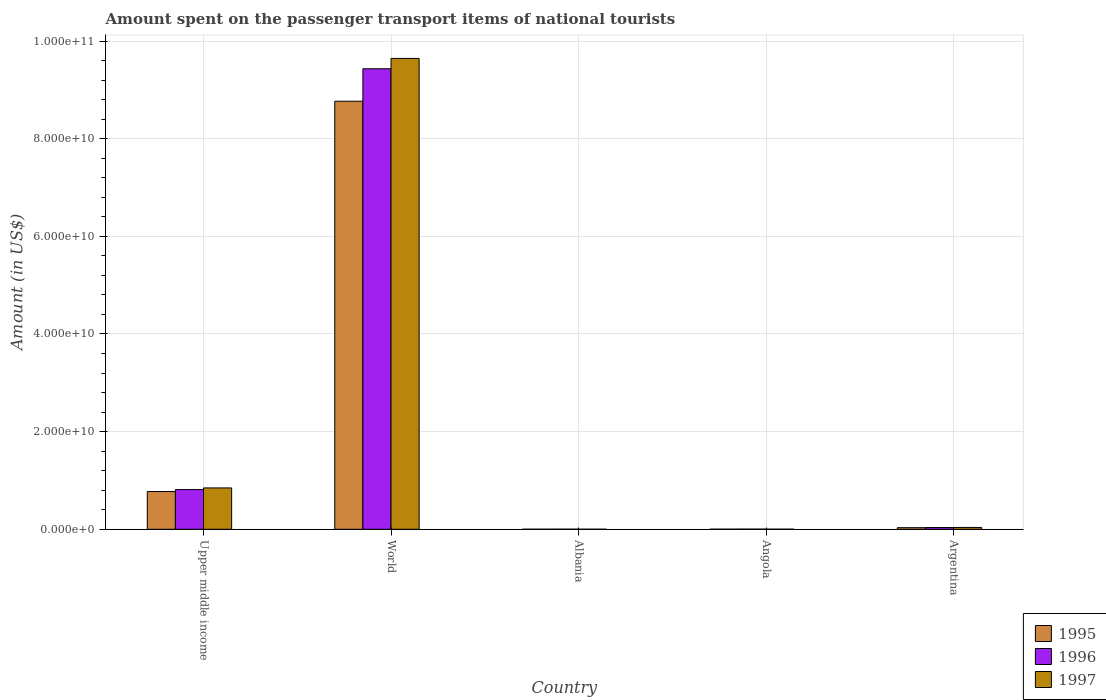How many different coloured bars are there?
Offer a terse response. 3. How many bars are there on the 3rd tick from the left?
Provide a succinct answer. 3. What is the label of the 4th group of bars from the left?
Make the answer very short. Angola. What is the amount spent on the passenger transport items of national tourists in 1997 in Upper middle income?
Your response must be concise. 8.47e+09. Across all countries, what is the maximum amount spent on the passenger transport items of national tourists in 1996?
Provide a succinct answer. 9.43e+1. Across all countries, what is the minimum amount spent on the passenger transport items of national tourists in 1996?
Give a very brief answer. 1.68e+07. In which country was the amount spent on the passenger transport items of national tourists in 1997 minimum?
Your answer should be very brief. Albania. What is the total amount spent on the passenger transport items of national tourists in 1996 in the graph?
Provide a succinct answer. 1.03e+11. What is the difference between the amount spent on the passenger transport items of national tourists in 1995 in Angola and that in Upper middle income?
Offer a terse response. -7.72e+09. What is the difference between the amount spent on the passenger transport items of national tourists in 1997 in Upper middle income and the amount spent on the passenger transport items of national tourists in 1996 in Argentina?
Your response must be concise. 8.12e+09. What is the average amount spent on the passenger transport items of national tourists in 1996 per country?
Offer a very short reply. 2.06e+1. What is the ratio of the amount spent on the passenger transport items of national tourists in 1995 in Angola to that in Upper middle income?
Your response must be concise. 0. Is the amount spent on the passenger transport items of national tourists in 1997 in Angola less than that in Argentina?
Provide a succinct answer. Yes. Is the difference between the amount spent on the passenger transport items of national tourists in 1997 in Albania and Angola greater than the difference between the amount spent on the passenger transport items of national tourists in 1995 in Albania and Angola?
Your answer should be compact. Yes. What is the difference between the highest and the second highest amount spent on the passenger transport items of national tourists in 1997?
Offer a very short reply. -8.09e+09. What is the difference between the highest and the lowest amount spent on the passenger transport items of national tourists in 1997?
Your answer should be compact. 9.64e+1. Is the sum of the amount spent on the passenger transport items of national tourists in 1997 in Albania and Upper middle income greater than the maximum amount spent on the passenger transport items of national tourists in 1996 across all countries?
Your answer should be very brief. No. Is it the case that in every country, the sum of the amount spent on the passenger transport items of national tourists in 1997 and amount spent on the passenger transport items of national tourists in 1996 is greater than the amount spent on the passenger transport items of national tourists in 1995?
Give a very brief answer. Yes. Are all the bars in the graph horizontal?
Ensure brevity in your answer.  No. Where does the legend appear in the graph?
Ensure brevity in your answer.  Bottom right. How many legend labels are there?
Keep it short and to the point. 3. What is the title of the graph?
Provide a short and direct response. Amount spent on the passenger transport items of national tourists. What is the label or title of the X-axis?
Make the answer very short. Country. What is the Amount (in US$) in 1995 in Upper middle income?
Your answer should be compact. 7.73e+09. What is the Amount (in US$) in 1996 in Upper middle income?
Your answer should be compact. 8.13e+09. What is the Amount (in US$) in 1997 in Upper middle income?
Offer a very short reply. 8.47e+09. What is the Amount (in US$) of 1995 in World?
Your answer should be very brief. 8.77e+1. What is the Amount (in US$) in 1996 in World?
Make the answer very short. 9.43e+1. What is the Amount (in US$) in 1997 in World?
Ensure brevity in your answer.  9.64e+1. What is the Amount (in US$) of 1995 in Albania?
Keep it short and to the point. 5.40e+06. What is the Amount (in US$) of 1996 in Albania?
Provide a succinct answer. 1.68e+07. What is the Amount (in US$) in 1997 in Albania?
Your answer should be very brief. 6.60e+06. What is the Amount (in US$) of 1995 in Angola?
Ensure brevity in your answer.  1.70e+07. What is the Amount (in US$) in 1996 in Angola?
Keep it short and to the point. 2.90e+07. What is the Amount (in US$) of 1997 in Angola?
Your answer should be very brief. 1.50e+07. What is the Amount (in US$) in 1995 in Argentina?
Make the answer very short. 3.28e+08. What is the Amount (in US$) in 1996 in Argentina?
Your answer should be very brief. 3.54e+08. What is the Amount (in US$) in 1997 in Argentina?
Ensure brevity in your answer.  3.75e+08. Across all countries, what is the maximum Amount (in US$) in 1995?
Your response must be concise. 8.77e+1. Across all countries, what is the maximum Amount (in US$) of 1996?
Ensure brevity in your answer.  9.43e+1. Across all countries, what is the maximum Amount (in US$) in 1997?
Keep it short and to the point. 9.64e+1. Across all countries, what is the minimum Amount (in US$) of 1995?
Offer a very short reply. 5.40e+06. Across all countries, what is the minimum Amount (in US$) of 1996?
Keep it short and to the point. 1.68e+07. Across all countries, what is the minimum Amount (in US$) of 1997?
Provide a short and direct response. 6.60e+06. What is the total Amount (in US$) of 1995 in the graph?
Your answer should be compact. 9.58e+1. What is the total Amount (in US$) of 1996 in the graph?
Give a very brief answer. 1.03e+11. What is the total Amount (in US$) of 1997 in the graph?
Make the answer very short. 1.05e+11. What is the difference between the Amount (in US$) of 1995 in Upper middle income and that in World?
Provide a succinct answer. -7.99e+1. What is the difference between the Amount (in US$) of 1996 in Upper middle income and that in World?
Keep it short and to the point. -8.62e+1. What is the difference between the Amount (in US$) in 1997 in Upper middle income and that in World?
Provide a short and direct response. -8.80e+1. What is the difference between the Amount (in US$) in 1995 in Upper middle income and that in Albania?
Your answer should be very brief. 7.73e+09. What is the difference between the Amount (in US$) of 1996 in Upper middle income and that in Albania?
Provide a short and direct response. 8.11e+09. What is the difference between the Amount (in US$) of 1997 in Upper middle income and that in Albania?
Offer a very short reply. 8.46e+09. What is the difference between the Amount (in US$) of 1995 in Upper middle income and that in Angola?
Keep it short and to the point. 7.72e+09. What is the difference between the Amount (in US$) of 1996 in Upper middle income and that in Angola?
Keep it short and to the point. 8.10e+09. What is the difference between the Amount (in US$) of 1997 in Upper middle income and that in Angola?
Give a very brief answer. 8.45e+09. What is the difference between the Amount (in US$) of 1995 in Upper middle income and that in Argentina?
Give a very brief answer. 7.41e+09. What is the difference between the Amount (in US$) of 1996 in Upper middle income and that in Argentina?
Provide a succinct answer. 7.78e+09. What is the difference between the Amount (in US$) in 1997 in Upper middle income and that in Argentina?
Your response must be concise. 8.09e+09. What is the difference between the Amount (in US$) in 1995 in World and that in Albania?
Offer a terse response. 8.77e+1. What is the difference between the Amount (in US$) in 1996 in World and that in Albania?
Provide a short and direct response. 9.43e+1. What is the difference between the Amount (in US$) in 1997 in World and that in Albania?
Your answer should be very brief. 9.64e+1. What is the difference between the Amount (in US$) in 1995 in World and that in Angola?
Provide a succinct answer. 8.77e+1. What is the difference between the Amount (in US$) in 1996 in World and that in Angola?
Ensure brevity in your answer.  9.43e+1. What is the difference between the Amount (in US$) in 1997 in World and that in Angola?
Give a very brief answer. 9.64e+1. What is the difference between the Amount (in US$) of 1995 in World and that in Argentina?
Ensure brevity in your answer.  8.73e+1. What is the difference between the Amount (in US$) of 1996 in World and that in Argentina?
Ensure brevity in your answer.  9.40e+1. What is the difference between the Amount (in US$) of 1997 in World and that in Argentina?
Provide a short and direct response. 9.61e+1. What is the difference between the Amount (in US$) of 1995 in Albania and that in Angola?
Your answer should be compact. -1.16e+07. What is the difference between the Amount (in US$) in 1996 in Albania and that in Angola?
Your response must be concise. -1.22e+07. What is the difference between the Amount (in US$) in 1997 in Albania and that in Angola?
Give a very brief answer. -8.40e+06. What is the difference between the Amount (in US$) in 1995 in Albania and that in Argentina?
Give a very brief answer. -3.23e+08. What is the difference between the Amount (in US$) of 1996 in Albania and that in Argentina?
Your response must be concise. -3.37e+08. What is the difference between the Amount (in US$) of 1997 in Albania and that in Argentina?
Offer a terse response. -3.69e+08. What is the difference between the Amount (in US$) in 1995 in Angola and that in Argentina?
Offer a terse response. -3.11e+08. What is the difference between the Amount (in US$) in 1996 in Angola and that in Argentina?
Keep it short and to the point. -3.25e+08. What is the difference between the Amount (in US$) in 1997 in Angola and that in Argentina?
Give a very brief answer. -3.60e+08. What is the difference between the Amount (in US$) in 1995 in Upper middle income and the Amount (in US$) in 1996 in World?
Keep it short and to the point. -8.66e+1. What is the difference between the Amount (in US$) in 1995 in Upper middle income and the Amount (in US$) in 1997 in World?
Provide a succinct answer. -8.87e+1. What is the difference between the Amount (in US$) of 1996 in Upper middle income and the Amount (in US$) of 1997 in World?
Your answer should be very brief. -8.83e+1. What is the difference between the Amount (in US$) of 1995 in Upper middle income and the Amount (in US$) of 1996 in Albania?
Provide a succinct answer. 7.72e+09. What is the difference between the Amount (in US$) of 1995 in Upper middle income and the Amount (in US$) of 1997 in Albania?
Ensure brevity in your answer.  7.73e+09. What is the difference between the Amount (in US$) of 1996 in Upper middle income and the Amount (in US$) of 1997 in Albania?
Your answer should be compact. 8.12e+09. What is the difference between the Amount (in US$) in 1995 in Upper middle income and the Amount (in US$) in 1996 in Angola?
Make the answer very short. 7.70e+09. What is the difference between the Amount (in US$) of 1995 in Upper middle income and the Amount (in US$) of 1997 in Angola?
Ensure brevity in your answer.  7.72e+09. What is the difference between the Amount (in US$) in 1996 in Upper middle income and the Amount (in US$) in 1997 in Angola?
Provide a short and direct response. 8.12e+09. What is the difference between the Amount (in US$) in 1995 in Upper middle income and the Amount (in US$) in 1996 in Argentina?
Give a very brief answer. 7.38e+09. What is the difference between the Amount (in US$) of 1995 in Upper middle income and the Amount (in US$) of 1997 in Argentina?
Keep it short and to the point. 7.36e+09. What is the difference between the Amount (in US$) of 1996 in Upper middle income and the Amount (in US$) of 1997 in Argentina?
Offer a very short reply. 7.76e+09. What is the difference between the Amount (in US$) in 1995 in World and the Amount (in US$) in 1996 in Albania?
Offer a terse response. 8.77e+1. What is the difference between the Amount (in US$) in 1995 in World and the Amount (in US$) in 1997 in Albania?
Offer a very short reply. 8.77e+1. What is the difference between the Amount (in US$) of 1996 in World and the Amount (in US$) of 1997 in Albania?
Ensure brevity in your answer.  9.43e+1. What is the difference between the Amount (in US$) in 1995 in World and the Amount (in US$) in 1996 in Angola?
Provide a short and direct response. 8.76e+1. What is the difference between the Amount (in US$) in 1995 in World and the Amount (in US$) in 1997 in Angola?
Ensure brevity in your answer.  8.77e+1. What is the difference between the Amount (in US$) in 1996 in World and the Amount (in US$) in 1997 in Angola?
Ensure brevity in your answer.  9.43e+1. What is the difference between the Amount (in US$) of 1995 in World and the Amount (in US$) of 1996 in Argentina?
Provide a short and direct response. 8.73e+1. What is the difference between the Amount (in US$) of 1995 in World and the Amount (in US$) of 1997 in Argentina?
Offer a very short reply. 8.73e+1. What is the difference between the Amount (in US$) in 1996 in World and the Amount (in US$) in 1997 in Argentina?
Keep it short and to the point. 9.39e+1. What is the difference between the Amount (in US$) of 1995 in Albania and the Amount (in US$) of 1996 in Angola?
Offer a very short reply. -2.36e+07. What is the difference between the Amount (in US$) of 1995 in Albania and the Amount (in US$) of 1997 in Angola?
Provide a succinct answer. -9.60e+06. What is the difference between the Amount (in US$) of 1996 in Albania and the Amount (in US$) of 1997 in Angola?
Your answer should be very brief. 1.80e+06. What is the difference between the Amount (in US$) of 1995 in Albania and the Amount (in US$) of 1996 in Argentina?
Provide a short and direct response. -3.49e+08. What is the difference between the Amount (in US$) in 1995 in Albania and the Amount (in US$) in 1997 in Argentina?
Keep it short and to the point. -3.70e+08. What is the difference between the Amount (in US$) of 1996 in Albania and the Amount (in US$) of 1997 in Argentina?
Give a very brief answer. -3.59e+08. What is the difference between the Amount (in US$) of 1995 in Angola and the Amount (in US$) of 1996 in Argentina?
Keep it short and to the point. -3.37e+08. What is the difference between the Amount (in US$) of 1995 in Angola and the Amount (in US$) of 1997 in Argentina?
Provide a short and direct response. -3.58e+08. What is the difference between the Amount (in US$) in 1996 in Angola and the Amount (in US$) in 1997 in Argentina?
Ensure brevity in your answer.  -3.46e+08. What is the average Amount (in US$) of 1995 per country?
Provide a succinct answer. 1.92e+1. What is the average Amount (in US$) of 1996 per country?
Keep it short and to the point. 2.06e+1. What is the average Amount (in US$) of 1997 per country?
Give a very brief answer. 2.11e+1. What is the difference between the Amount (in US$) in 1995 and Amount (in US$) in 1996 in Upper middle income?
Your response must be concise. -3.97e+08. What is the difference between the Amount (in US$) of 1995 and Amount (in US$) of 1997 in Upper middle income?
Provide a short and direct response. -7.36e+08. What is the difference between the Amount (in US$) in 1996 and Amount (in US$) in 1997 in Upper middle income?
Offer a very short reply. -3.39e+08. What is the difference between the Amount (in US$) of 1995 and Amount (in US$) of 1996 in World?
Your response must be concise. -6.65e+09. What is the difference between the Amount (in US$) in 1995 and Amount (in US$) in 1997 in World?
Make the answer very short. -8.77e+09. What is the difference between the Amount (in US$) of 1996 and Amount (in US$) of 1997 in World?
Keep it short and to the point. -2.12e+09. What is the difference between the Amount (in US$) of 1995 and Amount (in US$) of 1996 in Albania?
Offer a terse response. -1.14e+07. What is the difference between the Amount (in US$) of 1995 and Amount (in US$) of 1997 in Albania?
Provide a short and direct response. -1.20e+06. What is the difference between the Amount (in US$) in 1996 and Amount (in US$) in 1997 in Albania?
Provide a succinct answer. 1.02e+07. What is the difference between the Amount (in US$) in 1995 and Amount (in US$) in 1996 in Angola?
Give a very brief answer. -1.20e+07. What is the difference between the Amount (in US$) in 1995 and Amount (in US$) in 1997 in Angola?
Ensure brevity in your answer.  2.00e+06. What is the difference between the Amount (in US$) of 1996 and Amount (in US$) of 1997 in Angola?
Your answer should be compact. 1.40e+07. What is the difference between the Amount (in US$) of 1995 and Amount (in US$) of 1996 in Argentina?
Offer a very short reply. -2.60e+07. What is the difference between the Amount (in US$) in 1995 and Amount (in US$) in 1997 in Argentina?
Provide a short and direct response. -4.74e+07. What is the difference between the Amount (in US$) of 1996 and Amount (in US$) of 1997 in Argentina?
Offer a very short reply. -2.14e+07. What is the ratio of the Amount (in US$) in 1995 in Upper middle income to that in World?
Provide a succinct answer. 0.09. What is the ratio of the Amount (in US$) of 1996 in Upper middle income to that in World?
Give a very brief answer. 0.09. What is the ratio of the Amount (in US$) in 1997 in Upper middle income to that in World?
Offer a terse response. 0.09. What is the ratio of the Amount (in US$) in 1995 in Upper middle income to that in Albania?
Give a very brief answer. 1432.19. What is the ratio of the Amount (in US$) in 1996 in Upper middle income to that in Albania?
Offer a very short reply. 483.97. What is the ratio of the Amount (in US$) in 1997 in Upper middle income to that in Albania?
Your answer should be very brief. 1283.31. What is the ratio of the Amount (in US$) of 1995 in Upper middle income to that in Angola?
Provide a short and direct response. 454.93. What is the ratio of the Amount (in US$) in 1996 in Upper middle income to that in Angola?
Your answer should be compact. 280.37. What is the ratio of the Amount (in US$) of 1997 in Upper middle income to that in Angola?
Ensure brevity in your answer.  564.66. What is the ratio of the Amount (in US$) of 1995 in Upper middle income to that in Argentina?
Provide a short and direct response. 23.58. What is the ratio of the Amount (in US$) in 1996 in Upper middle income to that in Argentina?
Provide a succinct answer. 22.97. What is the ratio of the Amount (in US$) in 1997 in Upper middle income to that in Argentina?
Your response must be concise. 22.56. What is the ratio of the Amount (in US$) of 1995 in World to that in Albania?
Offer a terse response. 1.62e+04. What is the ratio of the Amount (in US$) in 1996 in World to that in Albania?
Offer a terse response. 5614.52. What is the ratio of the Amount (in US$) in 1997 in World to that in Albania?
Provide a short and direct response. 1.46e+04. What is the ratio of the Amount (in US$) of 1995 in World to that in Angola?
Make the answer very short. 5157.3. What is the ratio of the Amount (in US$) of 1996 in World to that in Angola?
Make the answer very short. 3252.55. What is the ratio of the Amount (in US$) of 1997 in World to that in Angola?
Ensure brevity in your answer.  6429.47. What is the ratio of the Amount (in US$) in 1995 in World to that in Argentina?
Your answer should be compact. 267.3. What is the ratio of the Amount (in US$) in 1996 in World to that in Argentina?
Ensure brevity in your answer.  266.45. What is the ratio of the Amount (in US$) of 1997 in World to that in Argentina?
Your response must be concise. 256.9. What is the ratio of the Amount (in US$) in 1995 in Albania to that in Angola?
Your answer should be very brief. 0.32. What is the ratio of the Amount (in US$) in 1996 in Albania to that in Angola?
Keep it short and to the point. 0.58. What is the ratio of the Amount (in US$) in 1997 in Albania to that in Angola?
Offer a terse response. 0.44. What is the ratio of the Amount (in US$) in 1995 in Albania to that in Argentina?
Make the answer very short. 0.02. What is the ratio of the Amount (in US$) in 1996 in Albania to that in Argentina?
Make the answer very short. 0.05. What is the ratio of the Amount (in US$) in 1997 in Albania to that in Argentina?
Your answer should be compact. 0.02. What is the ratio of the Amount (in US$) of 1995 in Angola to that in Argentina?
Provide a short and direct response. 0.05. What is the ratio of the Amount (in US$) in 1996 in Angola to that in Argentina?
Keep it short and to the point. 0.08. What is the difference between the highest and the second highest Amount (in US$) of 1995?
Ensure brevity in your answer.  7.99e+1. What is the difference between the highest and the second highest Amount (in US$) of 1996?
Your response must be concise. 8.62e+1. What is the difference between the highest and the second highest Amount (in US$) in 1997?
Provide a short and direct response. 8.80e+1. What is the difference between the highest and the lowest Amount (in US$) of 1995?
Ensure brevity in your answer.  8.77e+1. What is the difference between the highest and the lowest Amount (in US$) in 1996?
Your answer should be very brief. 9.43e+1. What is the difference between the highest and the lowest Amount (in US$) of 1997?
Ensure brevity in your answer.  9.64e+1. 